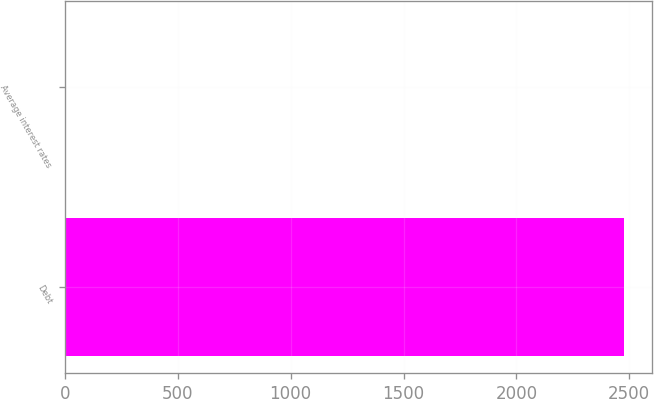<chart> <loc_0><loc_0><loc_500><loc_500><bar_chart><fcel>Debt<fcel>Average interest rates<nl><fcel>2476<fcel>5.2<nl></chart> 